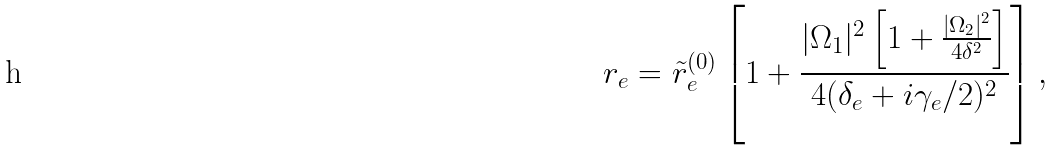Convert formula to latex. <formula><loc_0><loc_0><loc_500><loc_500>r _ { e } = \tilde { r } _ { e } ^ { ( 0 ) } \left [ 1 + \frac { | \Omega _ { 1 } | ^ { 2 } \left [ 1 + \frac { | \Omega _ { 2 } | ^ { 2 } } { 4 \delta ^ { 2 } } \right ] } { 4 ( \delta _ { e } + i \gamma _ { e } / 2 ) ^ { 2 } } \right ] ,</formula> 